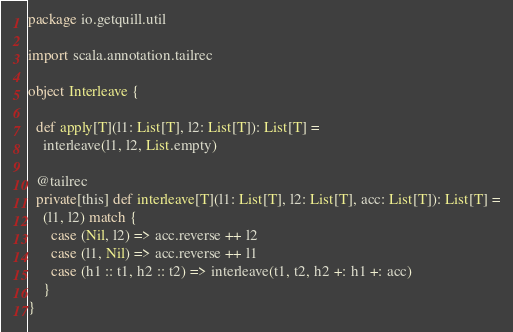<code> <loc_0><loc_0><loc_500><loc_500><_Scala_>package io.getquill.util

import scala.annotation.tailrec

object Interleave {

  def apply[T](l1: List[T], l2: List[T]): List[T] =
    interleave(l1, l2, List.empty)

  @tailrec
  private[this] def interleave[T](l1: List[T], l2: List[T], acc: List[T]): List[T] =
    (l1, l2) match {
      case (Nil, l2) => acc.reverse ++ l2
      case (l1, Nil) => acc.reverse ++ l1
      case (h1 :: t1, h2 :: t2) => interleave(t1, t2, h2 +: h1 +: acc)
    }
}
</code> 